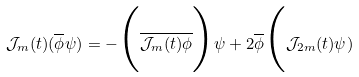<formula> <loc_0><loc_0><loc_500><loc_500>\mathcal { J } _ { m } ( t ) ( \overline { \phi } \psi ) = - \Big ( \overline { \mathcal { J } _ { m } ( t ) \phi } \Big ) \psi + 2 \overline { \phi } \Big ( \mathcal { J } _ { 2 m } ( t ) \psi )</formula> 